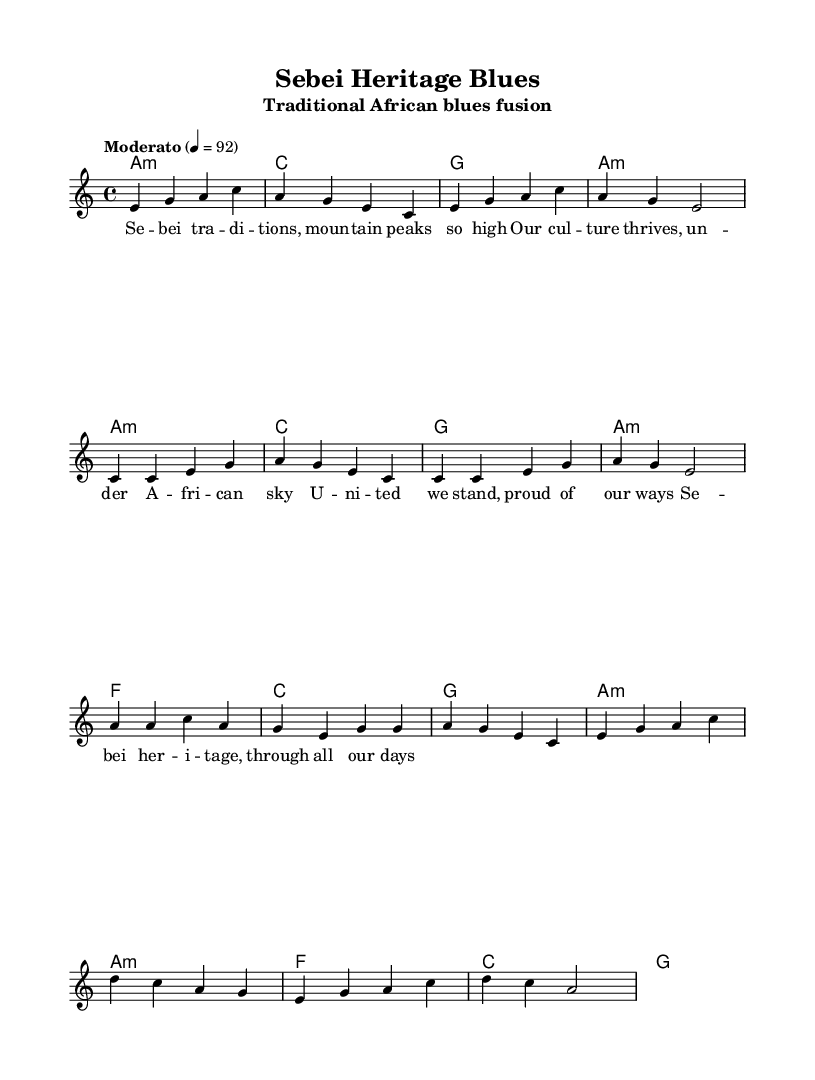What is the key signature of this music? The key signature is A minor, which has no sharps or flats, as indicated at the beginning of the staff.
Answer: A minor What is the time signature of the music? The time signature is 4/4, which is shown at the beginning of the sheet music, indicating there are four beats in each measure.
Answer: 4/4 What is the tempo marking of the piece? The tempo marking is "Moderato," which signifies a moderate speed for the piece, as noted in the tempo indication section.
Answer: Moderato How many sections does the music have? The music contains three main sections: an intro, a verse, and a chorus, which are distinguished by their different melodic lines.
Answer: Three Which section has the lyrics starting with "United we stand"? The lyrics starting with "United we stand" are found in the chorus section, as indicated by the label above the corresponding melody.
Answer: Chorus In what style is this piece composed? This piece is composed in a fusion style, incorporating traditional African elements with the blues genre, as indicated by the title and lyrics reflecting cultural heritage.
Answer: Traditional African blues fusion What chord is played during the chorus? The chorus features the F major chord prominently in the harmonic progression, as seen in the chord symbols above the melody during that section.
Answer: F major 